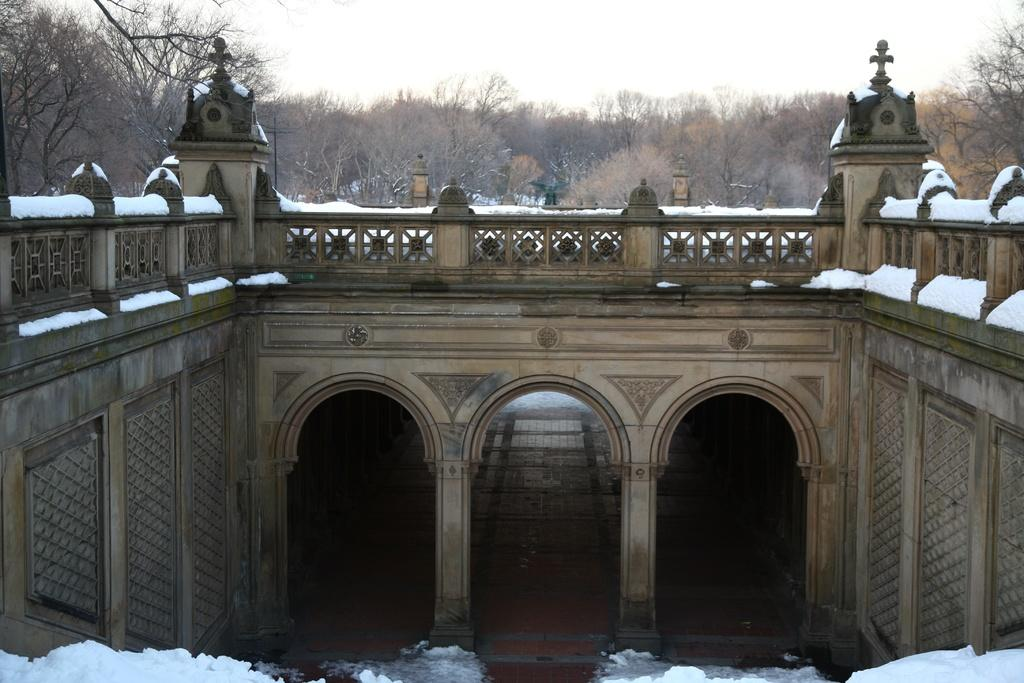What type of weather condition is depicted on the building in the image? There is snow on the building, indicating a winter scene. What can be seen behind the building? There are trees behind the building. What is visible at the top of the image? The sky is visible at the top of the image. How many dogs are playing in the park in the image? There are no dogs or park present in the image; it features a snow-covered building with trees behind it and a visible sky. 